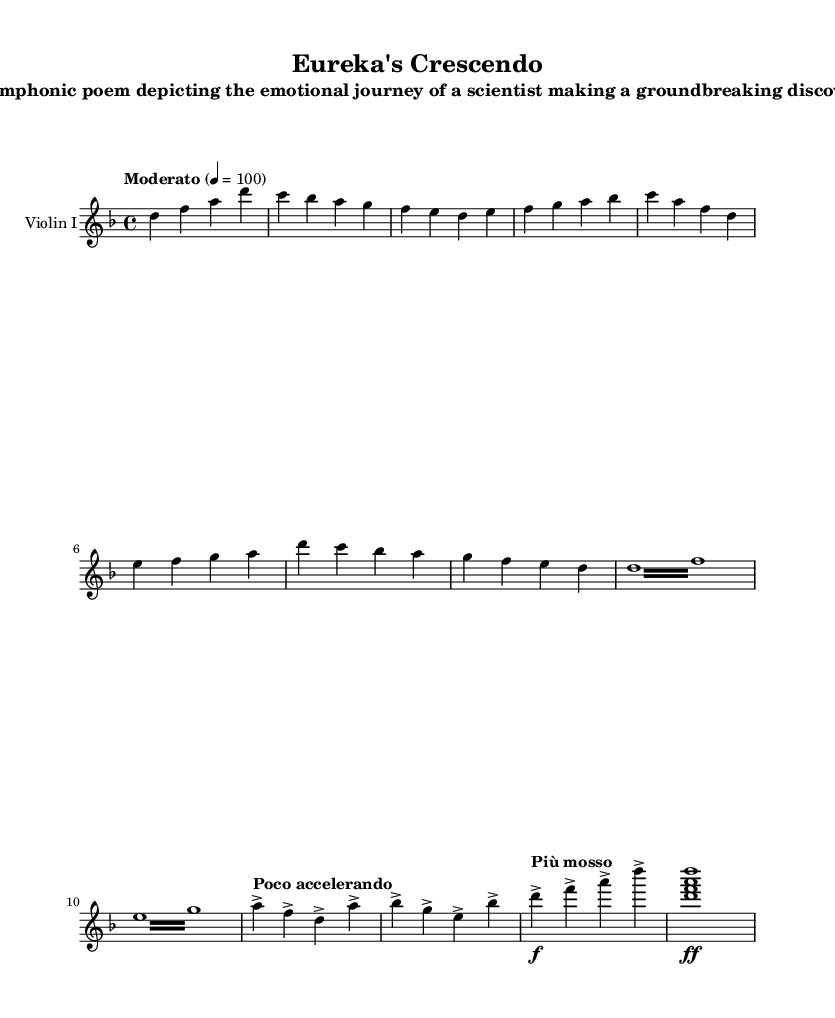What is the key signature of this music? The key signature shows two flats (B flat and E flat), indicating the piece is in D minor.
Answer: D minor What is the time signature of this music? The time signature is indicated at the beginning of the score and is written as a fraction with 4 on top and 4 on the bottom, signifying that there are four beats in a measure, and the quarter note receives one beat.
Answer: 4/4 What is the tempo indication at the start of the piece? The tempo marking is explicitly written as "Moderato" with a metronome marking of 100, providing both a descriptive and numerical tempo indication for the performance.
Answer: Moderato, 100 What musical term indicates a change in tempo towards the breakthrough moment? The term "Poco accelerando" directs the musician to gradually speed up the tempo leading into the breakthrough moment, capturing the increase in excitement and tension during this section.
Answer: Poco accelerando How does the mood change between Theme A and Theme B? Theme A conveys a sense of curiosity and research with ascending melodic lines, while Theme B introduces tension through repeated notes and intervallic leaps, evoking struggle and doubt in the process of discovery.
Answer: Curiosity to struggle What is the final dynamic marking for the coda section? The final dynamic marking, indicated by the symbol "ff," directs the performer to play this section very loudly, heightening the emotional impact as the work concludes.
Answer: ff What do the tremolo sections in Theme B imply about the scientist's emotional state? The use of tremolo (rapid alternation of notes) in Theme B emphasizes uncertainty and tension, reflecting the scientist's struggles and doubts during their research journey.
Answer: Tension and uncertainty 